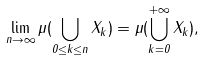Convert formula to latex. <formula><loc_0><loc_0><loc_500><loc_500>\lim _ { n \to \infty } \mu ( \bigcup _ { 0 \leq k \leq n } X _ { k } ) = \mu ( \bigcup _ { k = 0 } ^ { + \infty } X _ { k } ) ,</formula> 